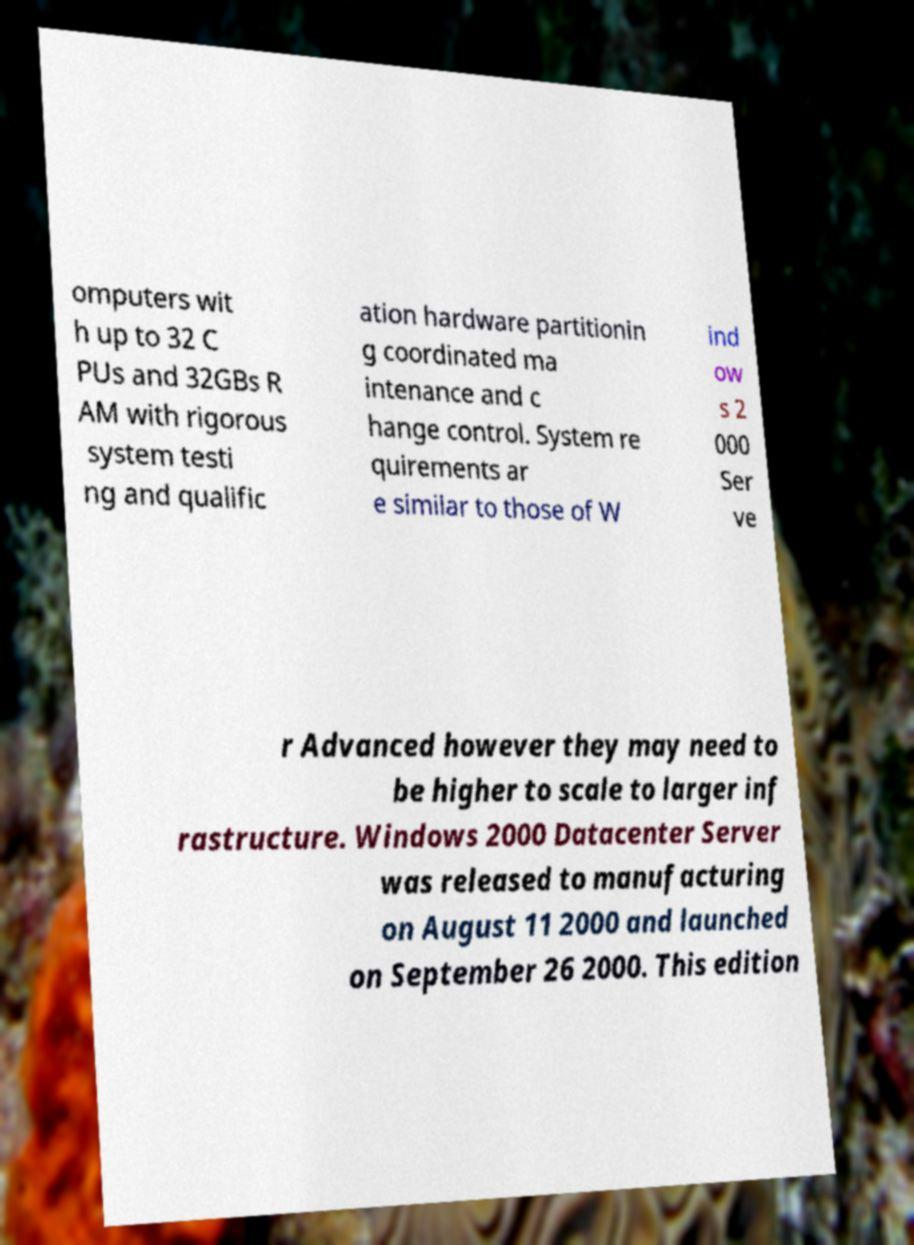Can you accurately transcribe the text from the provided image for me? omputers wit h up to 32 C PUs and 32GBs R AM with rigorous system testi ng and qualific ation hardware partitionin g coordinated ma intenance and c hange control. System re quirements ar e similar to those of W ind ow s 2 000 Ser ve r Advanced however they may need to be higher to scale to larger inf rastructure. Windows 2000 Datacenter Server was released to manufacturing on August 11 2000 and launched on September 26 2000. This edition 